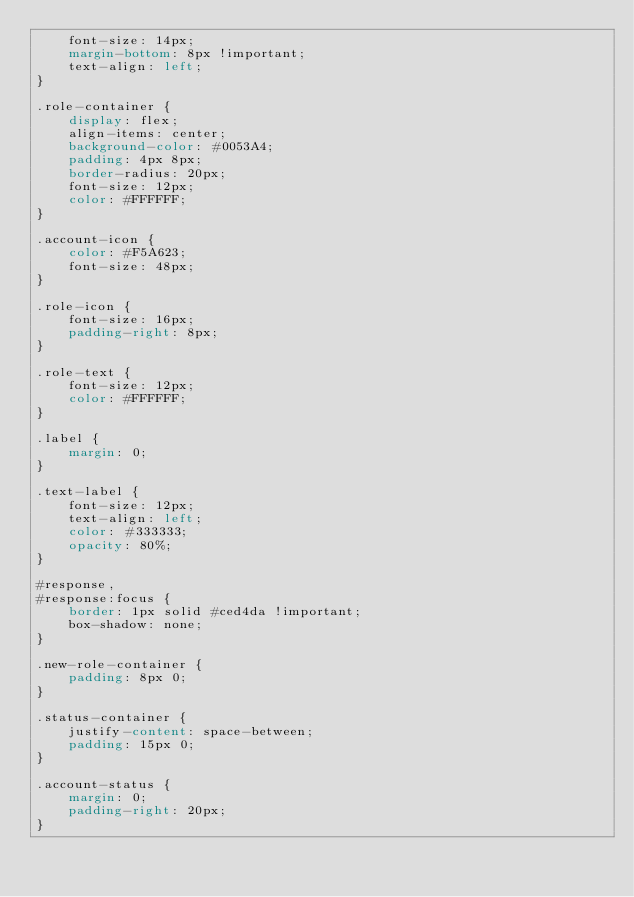Convert code to text. <code><loc_0><loc_0><loc_500><loc_500><_CSS_>    font-size: 14px;
    margin-bottom: 8px !important;
    text-align: left;
}

.role-container {
    display: flex;
    align-items: center;
    background-color: #0053A4;
    padding: 4px 8px;
    border-radius: 20px;
    font-size: 12px;
    color: #FFFFFF;
}

.account-icon {
    color: #F5A623;
    font-size: 48px;
}

.role-icon {
    font-size: 16px;
    padding-right: 8px;
}

.role-text {
    font-size: 12px;
    color: #FFFFFF;
}

.label {
    margin: 0;
}

.text-label {
    font-size: 12px;
    text-align: left;
    color: #333333;
    opacity: 80%;
}

#response,
#response:focus {
    border: 1px solid #ced4da !important;
    box-shadow: none;
}

.new-role-container {
    padding: 8px 0;
}

.status-container {
    justify-content: space-between;
    padding: 15px 0;
}

.account-status {
    margin: 0;
    padding-right: 20px;
}</code> 